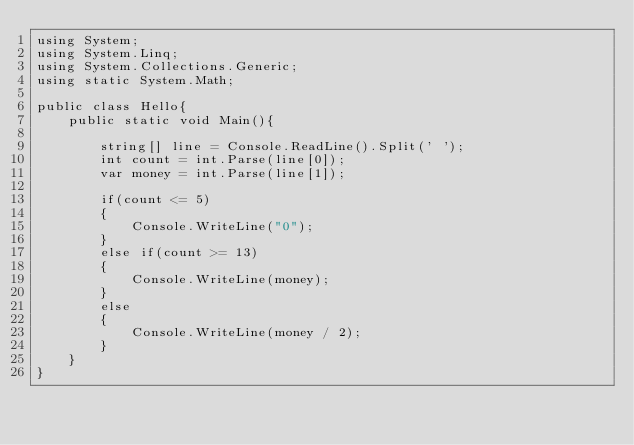Convert code to text. <code><loc_0><loc_0><loc_500><loc_500><_C#_>using System;
using System.Linq;
using System.Collections.Generic;
using static System.Math;

public class Hello{
    public static void Main(){

        string[] line = Console.ReadLine().Split(' ');
        int count = int.Parse(line[0]);
        var money = int.Parse(line[1]);

        if(count <= 5)
        {
            Console.WriteLine("0");
        }
        else if(count >= 13)
        {
            Console.WriteLine(money);
        }
        else 
        {
            Console.WriteLine(money / 2);
        }
    }
}</code> 